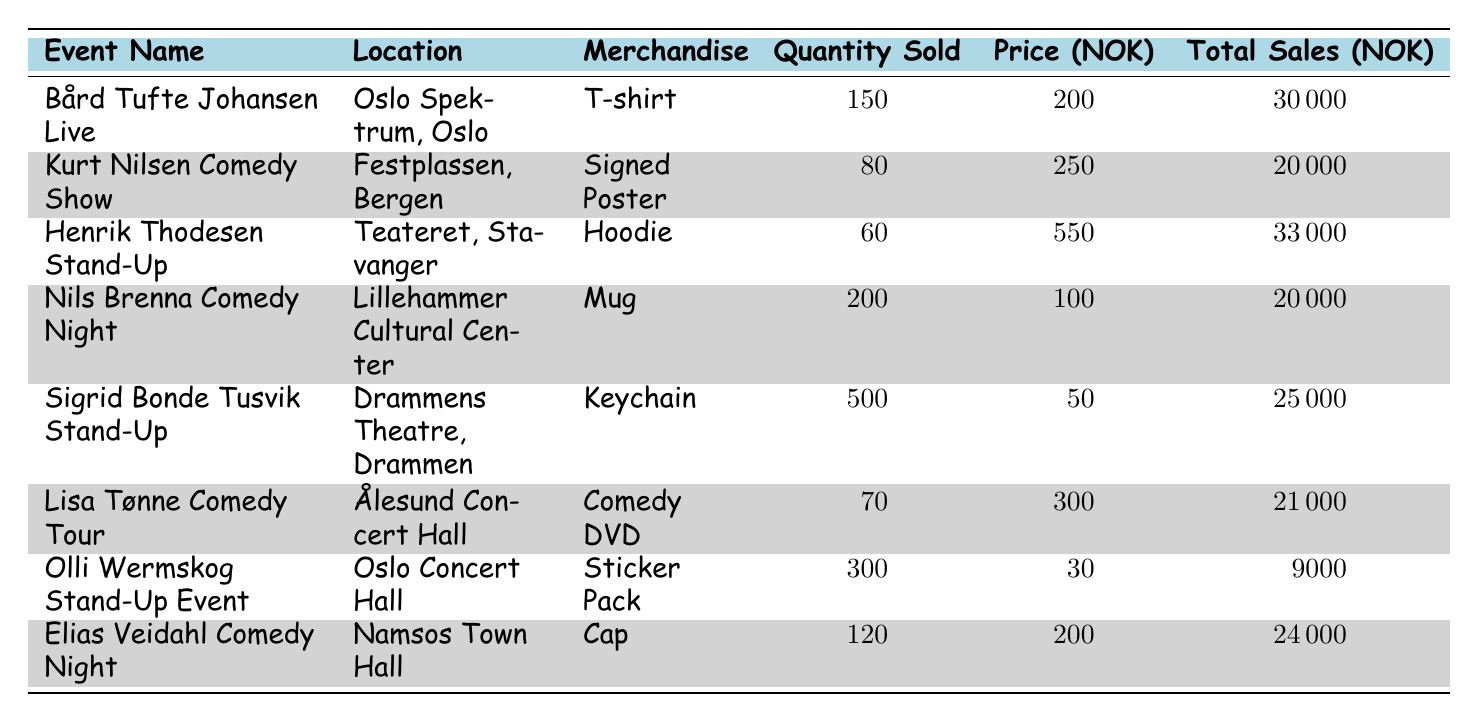What merchandise sold the most quantity? The "Keychain" sold the most with 500 units sold. It's located in the row for "Sigrid Bonde Tusvik Stand-Up" event.
Answer: Keychain Which event had the highest total sales? The event "Henrik Thodesen Stand-Up" had the highest total sales of 33,000 NOK, which is found in its respective row in the table.
Answer: Henrik Thodesen Stand-Up How many items were sold for the "Kurt Nilsen Comedy Show"? Looking at the row for "Kurt Nilsen Comedy Show," it shows that 80 Signed Posters were sold. Thus, the quantity of items sold is 80.
Answer: 80 What is the average price of the merchandise sold? To find the average price, sum all prices (200 + 250 + 550 + 100 + 50 + 300 + 30 + 200 = 1680) and divide by the number of merchandise types (8), resulting in 1680 / 8 = 210.
Answer: 210 Did the "Olli Wermskog Stand-Up Event" sell more items than the "Lisa Tønne Comedy Tour"? The "Olli Wermskog Stand-Up Event" sold 300 Sticker Packs, while the "Lisa Tønne Comedy Tour" sold 70 Comedy DVDs. Therefore, Olli Wermskog sold more items than Lisa Tønne.
Answer: Yes What is the total revenue for all events combined? Adding the total sales for each event gives 30,000 + 20,000 + 33,000 + 20,000 + 25,000 + 21,000 + 9,000 + 24,000 = 252,000. This represents the total revenue from all merchandise sales.
Answer: 252000 Which location had the lowest sales revenue? The lowest sales revenue was from "Olli Wermskog Stand-Up Event," with total sales of 9,000 NOK, as shown in its entry in the table.
Answer: Oslo Concert Hall How many more T-shirts were sold compared to Hoodies? There were 150 T-shirts sold ("Bård Tufte Johansen Live") and 60 Hoodies sold ("Henrik Thodesen Stand-Up"). The difference is 150 - 60 = 90.
Answer: 90 What percentage of total sales did the "Sticker Pack" contribute? To get the percentage, first, we find the sales for the "Sticker Pack" (9,000 NOK), then calculate the total sales (252,000 NOK). Finally, (9,000 / 252,000) * 100 = 3.57%.
Answer: 3.57% 